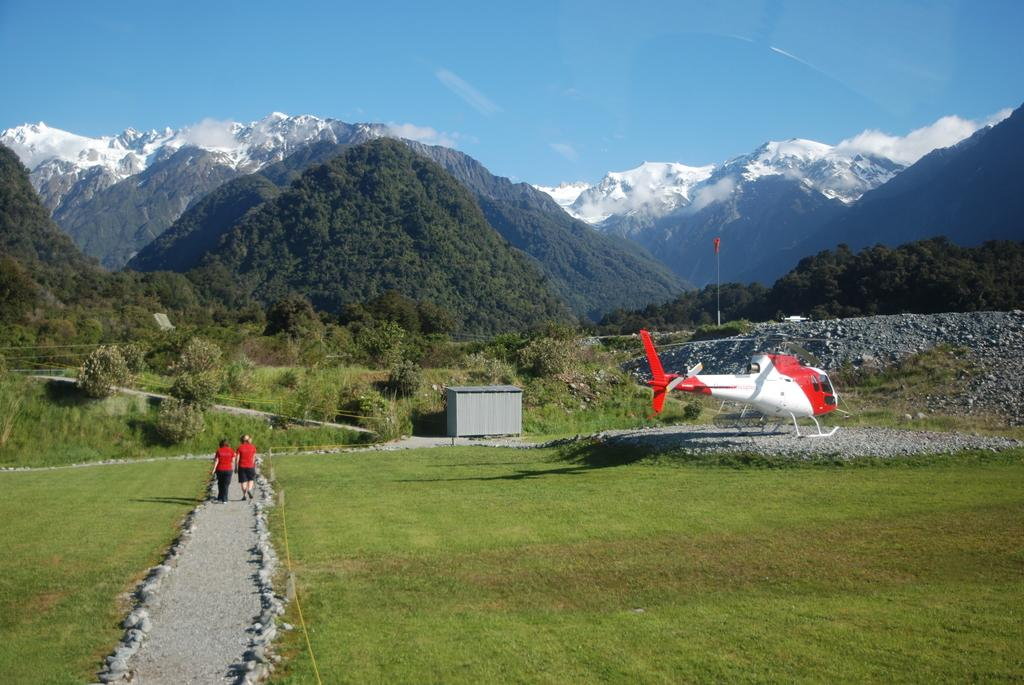What are the two people in the image doing? The two people in the image are walking on a path. What type of vegetation can be seen in the image? There is grass visible in the image. What else can be seen in the sky in the image? There is an airplane in the image. What type of structure is present in the image? There is a shed in the image. What other natural elements are present in the image? There are trees and hills in the image. What is the ground made of in the image? There are stones in the image. What is visible in the background of the image? The sky is visible in the background of the image. Where is the kitty hiding in the image? There is no kitty present in the image. 